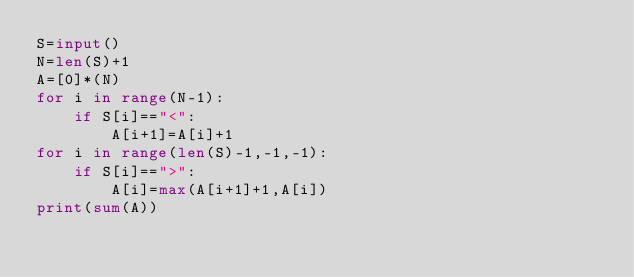Convert code to text. <code><loc_0><loc_0><loc_500><loc_500><_Python_>S=input()
N=len(S)+1
A=[0]*(N)
for i in range(N-1):
    if S[i]=="<":
        A[i+1]=A[i]+1
for i in range(len(S)-1,-1,-1):
    if S[i]==">":
        A[i]=max(A[i+1]+1,A[i])
print(sum(A))</code> 